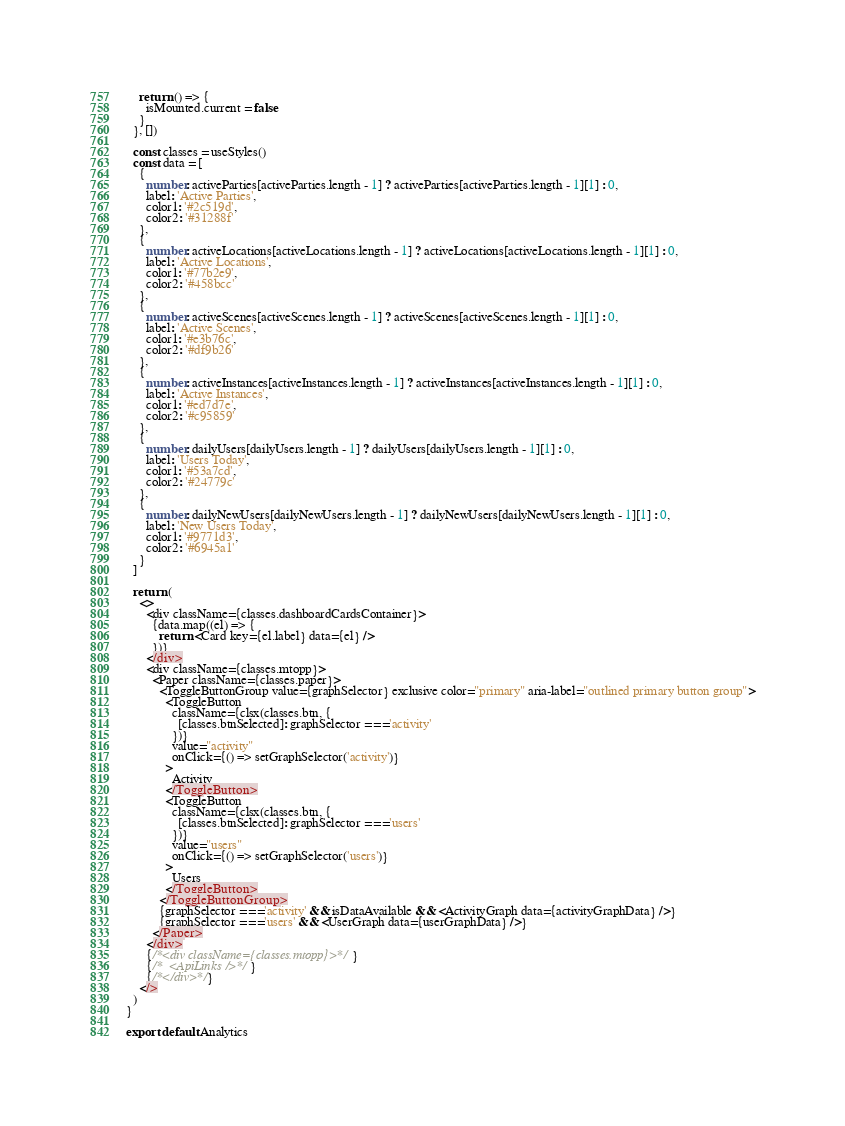<code> <loc_0><loc_0><loc_500><loc_500><_TypeScript_>    return () => {
      isMounted.current = false
    }
  }, [])

  const classes = useStyles()
  const data = [
    {
      number: activeParties[activeParties.length - 1] ? activeParties[activeParties.length - 1][1] : 0,
      label: 'Active Parties',
      color1: '#2c519d',
      color2: '#31288f'
    },
    {
      number: activeLocations[activeLocations.length - 1] ? activeLocations[activeLocations.length - 1][1] : 0,
      label: 'Active Locations',
      color1: '#77b2e9',
      color2: '#458bcc'
    },
    {
      number: activeScenes[activeScenes.length - 1] ? activeScenes[activeScenes.length - 1][1] : 0,
      label: 'Active Scenes',
      color1: '#e3b76c',
      color2: '#df9b26'
    },
    {
      number: activeInstances[activeInstances.length - 1] ? activeInstances[activeInstances.length - 1][1] : 0,
      label: 'Active Instances',
      color1: '#ed7d7e',
      color2: '#c95859'
    },
    {
      number: dailyUsers[dailyUsers.length - 1] ? dailyUsers[dailyUsers.length - 1][1] : 0,
      label: 'Users Today',
      color1: '#53a7cd',
      color2: '#24779c'
    },
    {
      number: dailyNewUsers[dailyNewUsers.length - 1] ? dailyNewUsers[dailyNewUsers.length - 1][1] : 0,
      label: 'New Users Today',
      color1: '#9771d3',
      color2: '#6945a1'
    }
  ]

  return (
    <>
      <div className={classes.dashboardCardsContainer}>
        {data.map((el) => {
          return <Card key={el.label} data={el} />
        })}
      </div>
      <div className={classes.mtopp}>
        <Paper className={classes.paper}>
          <ToggleButtonGroup value={graphSelector} exclusive color="primary" aria-label="outlined primary button group">
            <ToggleButton
              className={clsx(classes.btn, {
                [classes.btnSelected]: graphSelector === 'activity'
              })}
              value="activity"
              onClick={() => setGraphSelector('activity')}
            >
              Activity
            </ToggleButton>
            <ToggleButton
              className={clsx(classes.btn, {
                [classes.btnSelected]: graphSelector === 'users'
              })}
              value="users"
              onClick={() => setGraphSelector('users')}
            >
              Users
            </ToggleButton>
          </ToggleButtonGroup>
          {graphSelector === 'activity' && isDataAvailable && <ActivityGraph data={activityGraphData} />}
          {graphSelector === 'users' && <UserGraph data={userGraphData} />}
        </Paper>
      </div>
      {/*<div className={classes.mtopp}>*/}
      {/*  <ApiLinks />*/}
      {/*</div>*/}
    </>
  )
}

export default Analytics
</code> 